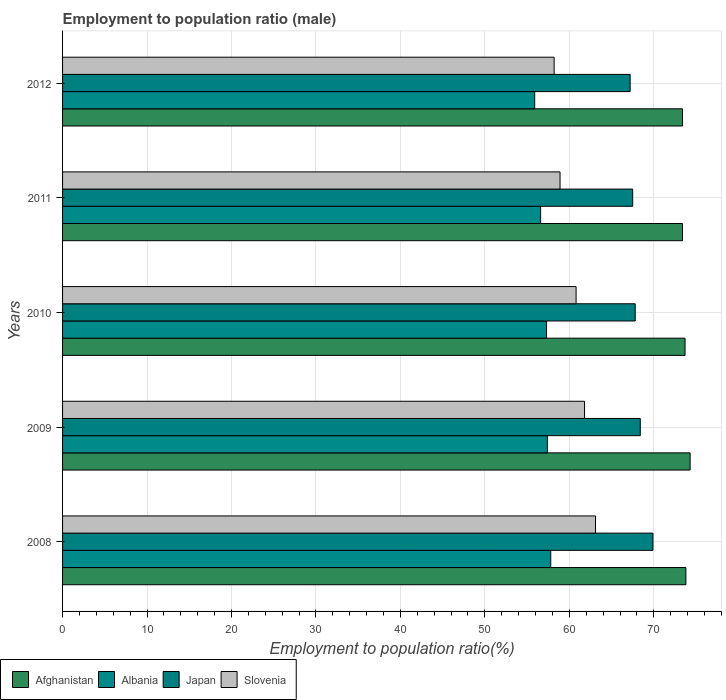How many different coloured bars are there?
Provide a succinct answer. 4. How many groups of bars are there?
Offer a terse response. 5. Are the number of bars on each tick of the Y-axis equal?
Ensure brevity in your answer.  Yes. What is the label of the 4th group of bars from the top?
Offer a very short reply. 2009. What is the employment to population ratio in Japan in 2012?
Your response must be concise. 67.2. Across all years, what is the maximum employment to population ratio in Albania?
Offer a very short reply. 57.8. Across all years, what is the minimum employment to population ratio in Albania?
Your answer should be very brief. 55.9. In which year was the employment to population ratio in Albania maximum?
Ensure brevity in your answer.  2008. In which year was the employment to population ratio in Japan minimum?
Make the answer very short. 2012. What is the total employment to population ratio in Afghanistan in the graph?
Give a very brief answer. 368.6. What is the difference between the employment to population ratio in Japan in 2008 and that in 2010?
Your answer should be compact. 2.1. What is the difference between the employment to population ratio in Slovenia in 2011 and the employment to population ratio in Albania in 2008?
Your answer should be compact. 1.1. What is the average employment to population ratio in Japan per year?
Your answer should be very brief. 68.16. In the year 2009, what is the difference between the employment to population ratio in Afghanistan and employment to population ratio in Slovenia?
Offer a very short reply. 12.5. What is the ratio of the employment to population ratio in Afghanistan in 2008 to that in 2012?
Your response must be concise. 1.01. Is the employment to population ratio in Afghanistan in 2008 less than that in 2011?
Provide a succinct answer. No. Is the difference between the employment to population ratio in Afghanistan in 2008 and 2010 greater than the difference between the employment to population ratio in Slovenia in 2008 and 2010?
Ensure brevity in your answer.  No. What is the difference between the highest and the second highest employment to population ratio in Albania?
Make the answer very short. 0.4. What is the difference between the highest and the lowest employment to population ratio in Afghanistan?
Keep it short and to the point. 0.9. In how many years, is the employment to population ratio in Albania greater than the average employment to population ratio in Albania taken over all years?
Offer a terse response. 3. Is the sum of the employment to population ratio in Slovenia in 2009 and 2011 greater than the maximum employment to population ratio in Afghanistan across all years?
Your response must be concise. Yes. Is it the case that in every year, the sum of the employment to population ratio in Albania and employment to population ratio in Japan is greater than the sum of employment to population ratio in Afghanistan and employment to population ratio in Slovenia?
Your response must be concise. No. What does the 4th bar from the top in 2012 represents?
Keep it short and to the point. Afghanistan. What does the 1st bar from the bottom in 2008 represents?
Your response must be concise. Afghanistan. Is it the case that in every year, the sum of the employment to population ratio in Afghanistan and employment to population ratio in Albania is greater than the employment to population ratio in Slovenia?
Give a very brief answer. Yes. How many bars are there?
Keep it short and to the point. 20. Are all the bars in the graph horizontal?
Keep it short and to the point. Yes. How many years are there in the graph?
Your answer should be compact. 5. Does the graph contain any zero values?
Offer a very short reply. No. Does the graph contain grids?
Keep it short and to the point. Yes. Where does the legend appear in the graph?
Give a very brief answer. Bottom left. How many legend labels are there?
Give a very brief answer. 4. What is the title of the graph?
Your answer should be very brief. Employment to population ratio (male). What is the Employment to population ratio(%) in Afghanistan in 2008?
Offer a terse response. 73.8. What is the Employment to population ratio(%) in Albania in 2008?
Provide a succinct answer. 57.8. What is the Employment to population ratio(%) in Japan in 2008?
Provide a succinct answer. 69.9. What is the Employment to population ratio(%) in Slovenia in 2008?
Make the answer very short. 63.1. What is the Employment to population ratio(%) of Afghanistan in 2009?
Your response must be concise. 74.3. What is the Employment to population ratio(%) of Albania in 2009?
Provide a succinct answer. 57.4. What is the Employment to population ratio(%) in Japan in 2009?
Provide a succinct answer. 68.4. What is the Employment to population ratio(%) in Slovenia in 2009?
Offer a terse response. 61.8. What is the Employment to population ratio(%) of Afghanistan in 2010?
Give a very brief answer. 73.7. What is the Employment to population ratio(%) of Albania in 2010?
Provide a short and direct response. 57.3. What is the Employment to population ratio(%) of Japan in 2010?
Give a very brief answer. 67.8. What is the Employment to population ratio(%) of Slovenia in 2010?
Provide a short and direct response. 60.8. What is the Employment to population ratio(%) of Afghanistan in 2011?
Offer a very short reply. 73.4. What is the Employment to population ratio(%) of Albania in 2011?
Offer a terse response. 56.6. What is the Employment to population ratio(%) of Japan in 2011?
Your answer should be compact. 67.5. What is the Employment to population ratio(%) in Slovenia in 2011?
Your answer should be compact. 58.9. What is the Employment to population ratio(%) in Afghanistan in 2012?
Your answer should be very brief. 73.4. What is the Employment to population ratio(%) in Albania in 2012?
Your answer should be compact. 55.9. What is the Employment to population ratio(%) of Japan in 2012?
Offer a very short reply. 67.2. What is the Employment to population ratio(%) of Slovenia in 2012?
Give a very brief answer. 58.2. Across all years, what is the maximum Employment to population ratio(%) of Afghanistan?
Make the answer very short. 74.3. Across all years, what is the maximum Employment to population ratio(%) of Albania?
Provide a short and direct response. 57.8. Across all years, what is the maximum Employment to population ratio(%) in Japan?
Give a very brief answer. 69.9. Across all years, what is the maximum Employment to population ratio(%) of Slovenia?
Provide a short and direct response. 63.1. Across all years, what is the minimum Employment to population ratio(%) in Afghanistan?
Provide a short and direct response. 73.4. Across all years, what is the minimum Employment to population ratio(%) in Albania?
Give a very brief answer. 55.9. Across all years, what is the minimum Employment to population ratio(%) of Japan?
Ensure brevity in your answer.  67.2. Across all years, what is the minimum Employment to population ratio(%) of Slovenia?
Offer a very short reply. 58.2. What is the total Employment to population ratio(%) of Afghanistan in the graph?
Provide a succinct answer. 368.6. What is the total Employment to population ratio(%) in Albania in the graph?
Ensure brevity in your answer.  285. What is the total Employment to population ratio(%) in Japan in the graph?
Provide a short and direct response. 340.8. What is the total Employment to population ratio(%) in Slovenia in the graph?
Make the answer very short. 302.8. What is the difference between the Employment to population ratio(%) in Afghanistan in 2008 and that in 2009?
Keep it short and to the point. -0.5. What is the difference between the Employment to population ratio(%) of Albania in 2008 and that in 2009?
Provide a short and direct response. 0.4. What is the difference between the Employment to population ratio(%) of Japan in 2008 and that in 2009?
Provide a short and direct response. 1.5. What is the difference between the Employment to population ratio(%) in Slovenia in 2008 and that in 2009?
Your answer should be compact. 1.3. What is the difference between the Employment to population ratio(%) in Afghanistan in 2008 and that in 2010?
Offer a very short reply. 0.1. What is the difference between the Employment to population ratio(%) of Albania in 2008 and that in 2012?
Your response must be concise. 1.9. What is the difference between the Employment to population ratio(%) of Japan in 2008 and that in 2012?
Keep it short and to the point. 2.7. What is the difference between the Employment to population ratio(%) of Slovenia in 2008 and that in 2012?
Offer a terse response. 4.9. What is the difference between the Employment to population ratio(%) of Afghanistan in 2009 and that in 2010?
Your answer should be very brief. 0.6. What is the difference between the Employment to population ratio(%) in Albania in 2009 and that in 2010?
Provide a short and direct response. 0.1. What is the difference between the Employment to population ratio(%) of Japan in 2009 and that in 2010?
Give a very brief answer. 0.6. What is the difference between the Employment to population ratio(%) of Albania in 2009 and that in 2011?
Keep it short and to the point. 0.8. What is the difference between the Employment to population ratio(%) in Japan in 2009 and that in 2011?
Offer a very short reply. 0.9. What is the difference between the Employment to population ratio(%) in Afghanistan in 2009 and that in 2012?
Provide a succinct answer. 0.9. What is the difference between the Employment to population ratio(%) in Albania in 2009 and that in 2012?
Give a very brief answer. 1.5. What is the difference between the Employment to population ratio(%) of Afghanistan in 2010 and that in 2011?
Give a very brief answer. 0.3. What is the difference between the Employment to population ratio(%) of Japan in 2010 and that in 2011?
Offer a very short reply. 0.3. What is the difference between the Employment to population ratio(%) in Slovenia in 2010 and that in 2011?
Make the answer very short. 1.9. What is the difference between the Employment to population ratio(%) of Japan in 2011 and that in 2012?
Provide a short and direct response. 0.3. What is the difference between the Employment to population ratio(%) of Slovenia in 2011 and that in 2012?
Provide a succinct answer. 0.7. What is the difference between the Employment to population ratio(%) in Afghanistan in 2008 and the Employment to population ratio(%) in Japan in 2009?
Your answer should be very brief. 5.4. What is the difference between the Employment to population ratio(%) of Afghanistan in 2008 and the Employment to population ratio(%) of Slovenia in 2009?
Provide a short and direct response. 12. What is the difference between the Employment to population ratio(%) in Japan in 2008 and the Employment to population ratio(%) in Slovenia in 2009?
Give a very brief answer. 8.1. What is the difference between the Employment to population ratio(%) in Afghanistan in 2008 and the Employment to population ratio(%) in Slovenia in 2010?
Your response must be concise. 13. What is the difference between the Employment to population ratio(%) of Albania in 2008 and the Employment to population ratio(%) of Slovenia in 2010?
Offer a terse response. -3. What is the difference between the Employment to population ratio(%) of Afghanistan in 2008 and the Employment to population ratio(%) of Albania in 2011?
Provide a short and direct response. 17.2. What is the difference between the Employment to population ratio(%) of Afghanistan in 2008 and the Employment to population ratio(%) of Japan in 2011?
Your answer should be compact. 6.3. What is the difference between the Employment to population ratio(%) of Afghanistan in 2008 and the Employment to population ratio(%) of Slovenia in 2011?
Provide a succinct answer. 14.9. What is the difference between the Employment to population ratio(%) in Albania in 2008 and the Employment to population ratio(%) in Japan in 2011?
Ensure brevity in your answer.  -9.7. What is the difference between the Employment to population ratio(%) of Afghanistan in 2008 and the Employment to population ratio(%) of Japan in 2012?
Your answer should be compact. 6.6. What is the difference between the Employment to population ratio(%) in Albania in 2008 and the Employment to population ratio(%) in Slovenia in 2012?
Ensure brevity in your answer.  -0.4. What is the difference between the Employment to population ratio(%) in Japan in 2008 and the Employment to population ratio(%) in Slovenia in 2012?
Provide a short and direct response. 11.7. What is the difference between the Employment to population ratio(%) of Afghanistan in 2009 and the Employment to population ratio(%) of Japan in 2010?
Provide a short and direct response. 6.5. What is the difference between the Employment to population ratio(%) of Afghanistan in 2009 and the Employment to population ratio(%) of Slovenia in 2010?
Keep it short and to the point. 13.5. What is the difference between the Employment to population ratio(%) in Albania in 2009 and the Employment to population ratio(%) in Japan in 2010?
Your response must be concise. -10.4. What is the difference between the Employment to population ratio(%) in Albania in 2009 and the Employment to population ratio(%) in Slovenia in 2010?
Give a very brief answer. -3.4. What is the difference between the Employment to population ratio(%) of Japan in 2009 and the Employment to population ratio(%) of Slovenia in 2010?
Offer a terse response. 7.6. What is the difference between the Employment to population ratio(%) in Afghanistan in 2009 and the Employment to population ratio(%) in Albania in 2011?
Ensure brevity in your answer.  17.7. What is the difference between the Employment to population ratio(%) of Afghanistan in 2009 and the Employment to population ratio(%) of Japan in 2011?
Your response must be concise. 6.8. What is the difference between the Employment to population ratio(%) in Albania in 2009 and the Employment to population ratio(%) in Japan in 2011?
Make the answer very short. -10.1. What is the difference between the Employment to population ratio(%) of Japan in 2009 and the Employment to population ratio(%) of Slovenia in 2011?
Keep it short and to the point. 9.5. What is the difference between the Employment to population ratio(%) of Albania in 2009 and the Employment to population ratio(%) of Slovenia in 2012?
Give a very brief answer. -0.8. What is the difference between the Employment to population ratio(%) in Afghanistan in 2010 and the Employment to population ratio(%) in Albania in 2011?
Make the answer very short. 17.1. What is the difference between the Employment to population ratio(%) of Afghanistan in 2010 and the Employment to population ratio(%) of Japan in 2011?
Offer a terse response. 6.2. What is the difference between the Employment to population ratio(%) of Afghanistan in 2010 and the Employment to population ratio(%) of Slovenia in 2011?
Provide a succinct answer. 14.8. What is the difference between the Employment to population ratio(%) in Albania in 2010 and the Employment to population ratio(%) in Slovenia in 2011?
Your answer should be very brief. -1.6. What is the difference between the Employment to population ratio(%) of Japan in 2010 and the Employment to population ratio(%) of Slovenia in 2011?
Give a very brief answer. 8.9. What is the difference between the Employment to population ratio(%) in Afghanistan in 2010 and the Employment to population ratio(%) in Albania in 2012?
Keep it short and to the point. 17.8. What is the difference between the Employment to population ratio(%) of Afghanistan in 2010 and the Employment to population ratio(%) of Slovenia in 2012?
Your response must be concise. 15.5. What is the difference between the Employment to population ratio(%) in Albania in 2010 and the Employment to population ratio(%) in Japan in 2012?
Offer a terse response. -9.9. What is the difference between the Employment to population ratio(%) of Albania in 2010 and the Employment to population ratio(%) of Slovenia in 2012?
Provide a succinct answer. -0.9. What is the difference between the Employment to population ratio(%) of Afghanistan in 2011 and the Employment to population ratio(%) of Albania in 2012?
Ensure brevity in your answer.  17.5. What is the difference between the Employment to population ratio(%) in Afghanistan in 2011 and the Employment to population ratio(%) in Slovenia in 2012?
Your answer should be very brief. 15.2. What is the difference between the Employment to population ratio(%) in Albania in 2011 and the Employment to population ratio(%) in Japan in 2012?
Offer a very short reply. -10.6. What is the average Employment to population ratio(%) in Afghanistan per year?
Offer a terse response. 73.72. What is the average Employment to population ratio(%) in Albania per year?
Give a very brief answer. 57. What is the average Employment to population ratio(%) of Japan per year?
Provide a succinct answer. 68.16. What is the average Employment to population ratio(%) of Slovenia per year?
Your response must be concise. 60.56. In the year 2008, what is the difference between the Employment to population ratio(%) of Afghanistan and Employment to population ratio(%) of Albania?
Your answer should be compact. 16. In the year 2008, what is the difference between the Employment to population ratio(%) in Albania and Employment to population ratio(%) in Japan?
Provide a short and direct response. -12.1. In the year 2008, what is the difference between the Employment to population ratio(%) of Albania and Employment to population ratio(%) of Slovenia?
Make the answer very short. -5.3. In the year 2008, what is the difference between the Employment to population ratio(%) of Japan and Employment to population ratio(%) of Slovenia?
Your answer should be compact. 6.8. In the year 2009, what is the difference between the Employment to population ratio(%) of Afghanistan and Employment to population ratio(%) of Japan?
Your answer should be very brief. 5.9. In the year 2009, what is the difference between the Employment to population ratio(%) in Albania and Employment to population ratio(%) in Slovenia?
Ensure brevity in your answer.  -4.4. In the year 2009, what is the difference between the Employment to population ratio(%) of Japan and Employment to population ratio(%) of Slovenia?
Your answer should be very brief. 6.6. In the year 2010, what is the difference between the Employment to population ratio(%) of Afghanistan and Employment to population ratio(%) of Albania?
Make the answer very short. 16.4. In the year 2010, what is the difference between the Employment to population ratio(%) of Afghanistan and Employment to population ratio(%) of Slovenia?
Ensure brevity in your answer.  12.9. In the year 2011, what is the difference between the Employment to population ratio(%) in Afghanistan and Employment to population ratio(%) in Japan?
Your answer should be compact. 5.9. In the year 2011, what is the difference between the Employment to population ratio(%) of Afghanistan and Employment to population ratio(%) of Slovenia?
Your answer should be very brief. 14.5. In the year 2011, what is the difference between the Employment to population ratio(%) of Japan and Employment to population ratio(%) of Slovenia?
Offer a very short reply. 8.6. In the year 2012, what is the difference between the Employment to population ratio(%) of Albania and Employment to population ratio(%) of Japan?
Your answer should be compact. -11.3. In the year 2012, what is the difference between the Employment to population ratio(%) in Japan and Employment to population ratio(%) in Slovenia?
Your response must be concise. 9. What is the ratio of the Employment to population ratio(%) of Japan in 2008 to that in 2009?
Offer a very short reply. 1.02. What is the ratio of the Employment to population ratio(%) of Albania in 2008 to that in 2010?
Your answer should be compact. 1.01. What is the ratio of the Employment to population ratio(%) of Japan in 2008 to that in 2010?
Your answer should be very brief. 1.03. What is the ratio of the Employment to population ratio(%) of Slovenia in 2008 to that in 2010?
Ensure brevity in your answer.  1.04. What is the ratio of the Employment to population ratio(%) in Afghanistan in 2008 to that in 2011?
Provide a short and direct response. 1.01. What is the ratio of the Employment to population ratio(%) in Albania in 2008 to that in 2011?
Give a very brief answer. 1.02. What is the ratio of the Employment to population ratio(%) in Japan in 2008 to that in 2011?
Your answer should be compact. 1.04. What is the ratio of the Employment to population ratio(%) of Slovenia in 2008 to that in 2011?
Offer a terse response. 1.07. What is the ratio of the Employment to population ratio(%) in Afghanistan in 2008 to that in 2012?
Provide a short and direct response. 1.01. What is the ratio of the Employment to population ratio(%) of Albania in 2008 to that in 2012?
Your answer should be very brief. 1.03. What is the ratio of the Employment to population ratio(%) in Japan in 2008 to that in 2012?
Provide a succinct answer. 1.04. What is the ratio of the Employment to population ratio(%) in Slovenia in 2008 to that in 2012?
Provide a short and direct response. 1.08. What is the ratio of the Employment to population ratio(%) in Afghanistan in 2009 to that in 2010?
Your answer should be compact. 1.01. What is the ratio of the Employment to population ratio(%) in Albania in 2009 to that in 2010?
Offer a very short reply. 1. What is the ratio of the Employment to population ratio(%) in Japan in 2009 to that in 2010?
Offer a very short reply. 1.01. What is the ratio of the Employment to population ratio(%) of Slovenia in 2009 to that in 2010?
Your answer should be compact. 1.02. What is the ratio of the Employment to population ratio(%) of Afghanistan in 2009 to that in 2011?
Make the answer very short. 1.01. What is the ratio of the Employment to population ratio(%) of Albania in 2009 to that in 2011?
Your response must be concise. 1.01. What is the ratio of the Employment to population ratio(%) of Japan in 2009 to that in 2011?
Offer a very short reply. 1.01. What is the ratio of the Employment to population ratio(%) of Slovenia in 2009 to that in 2011?
Offer a very short reply. 1.05. What is the ratio of the Employment to population ratio(%) in Afghanistan in 2009 to that in 2012?
Provide a short and direct response. 1.01. What is the ratio of the Employment to population ratio(%) in Albania in 2009 to that in 2012?
Make the answer very short. 1.03. What is the ratio of the Employment to population ratio(%) in Japan in 2009 to that in 2012?
Offer a terse response. 1.02. What is the ratio of the Employment to population ratio(%) in Slovenia in 2009 to that in 2012?
Ensure brevity in your answer.  1.06. What is the ratio of the Employment to population ratio(%) of Albania in 2010 to that in 2011?
Your answer should be very brief. 1.01. What is the ratio of the Employment to population ratio(%) in Slovenia in 2010 to that in 2011?
Provide a short and direct response. 1.03. What is the ratio of the Employment to population ratio(%) of Albania in 2010 to that in 2012?
Keep it short and to the point. 1.02. What is the ratio of the Employment to population ratio(%) in Japan in 2010 to that in 2012?
Offer a very short reply. 1.01. What is the ratio of the Employment to population ratio(%) in Slovenia in 2010 to that in 2012?
Offer a terse response. 1.04. What is the ratio of the Employment to population ratio(%) in Afghanistan in 2011 to that in 2012?
Offer a very short reply. 1. What is the ratio of the Employment to population ratio(%) in Albania in 2011 to that in 2012?
Offer a very short reply. 1.01. What is the ratio of the Employment to population ratio(%) in Slovenia in 2011 to that in 2012?
Ensure brevity in your answer.  1.01. What is the difference between the highest and the second highest Employment to population ratio(%) in Slovenia?
Your response must be concise. 1.3. What is the difference between the highest and the lowest Employment to population ratio(%) of Afghanistan?
Offer a very short reply. 0.9. What is the difference between the highest and the lowest Employment to population ratio(%) of Slovenia?
Ensure brevity in your answer.  4.9. 